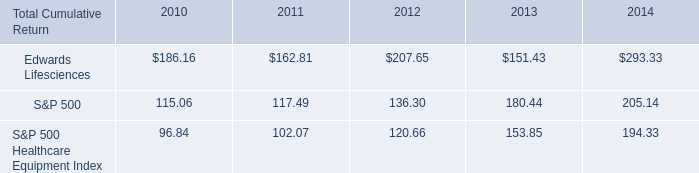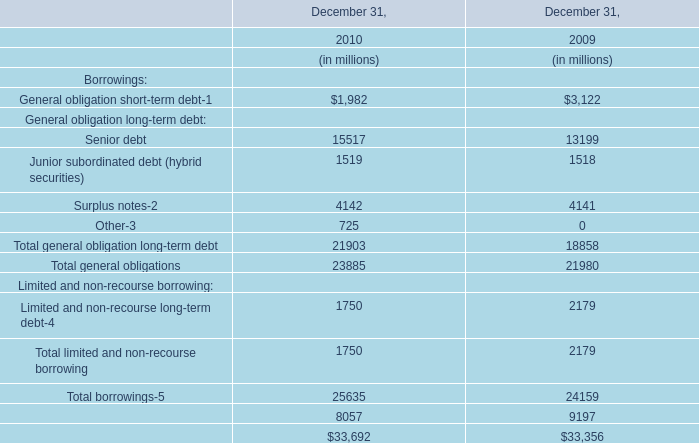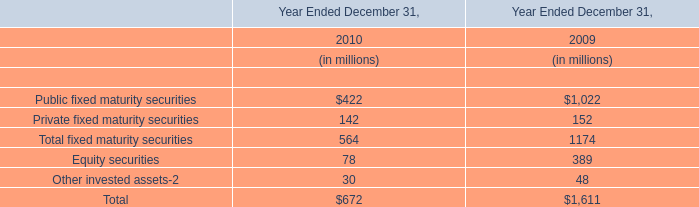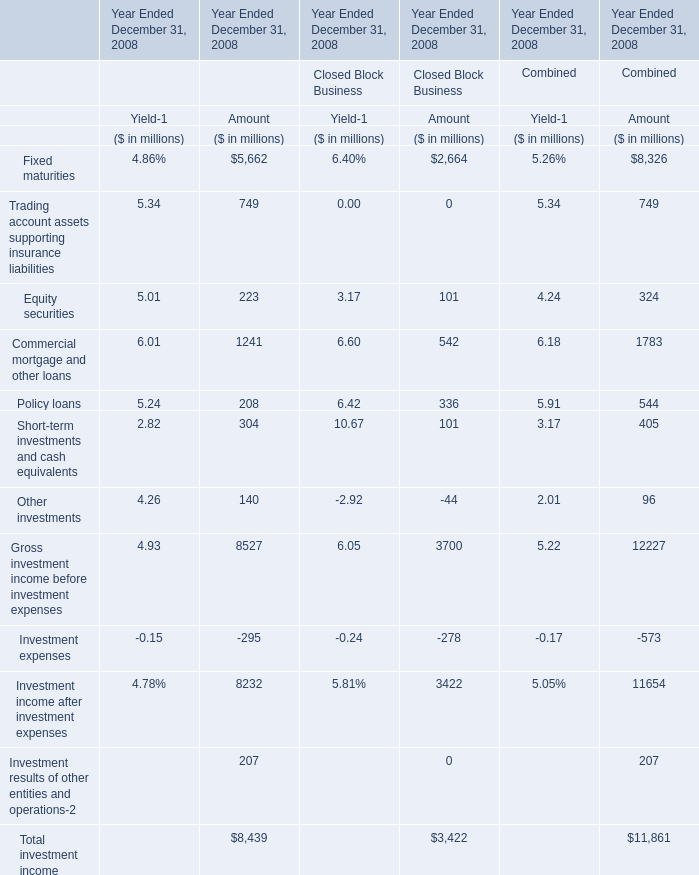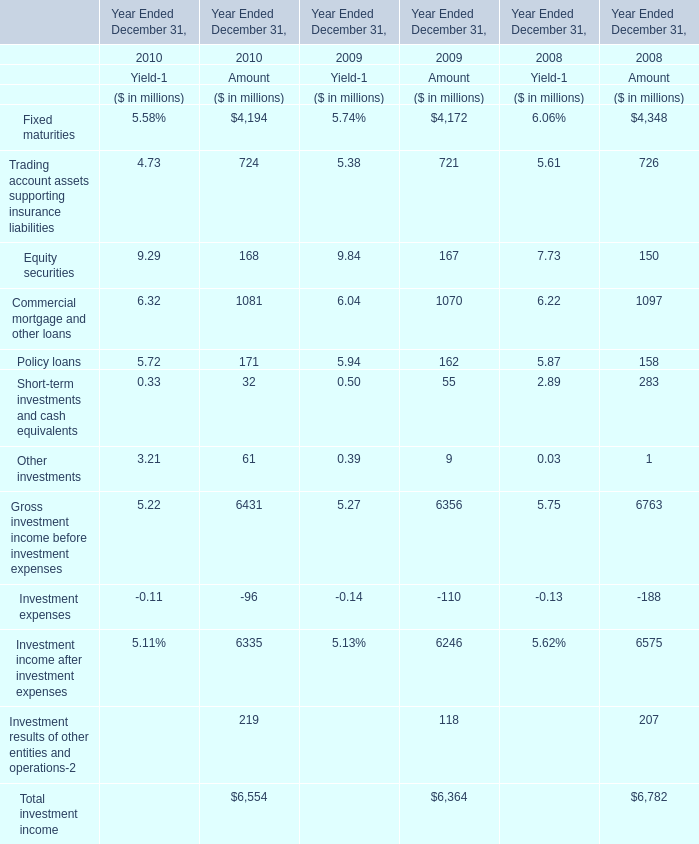What was the sum of closed block business of amount without those Gross investment income before investment expenses greater than 500, in 2008? (in million) 
Computations: (2664 + 542)
Answer: 3206.0. 